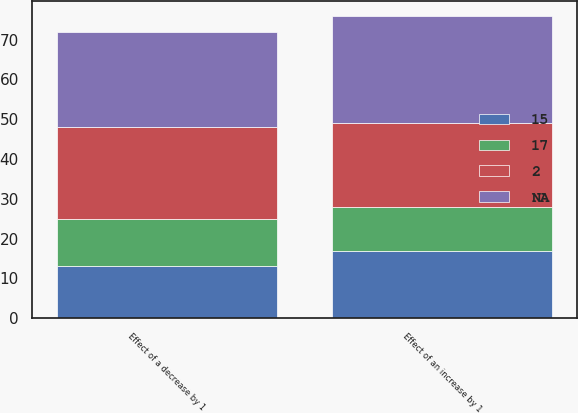Convert chart. <chart><loc_0><loc_0><loc_500><loc_500><stacked_bar_chart><ecel><fcel>Effect of an increase by 1<fcel>Effect of a decrease by 1<nl><fcel>nan<fcel>27<fcel>24<nl><fcel>17<fcel>11<fcel>12<nl><fcel>15<fcel>17<fcel>13<nl><fcel>2<fcel>21<fcel>23<nl></chart> 